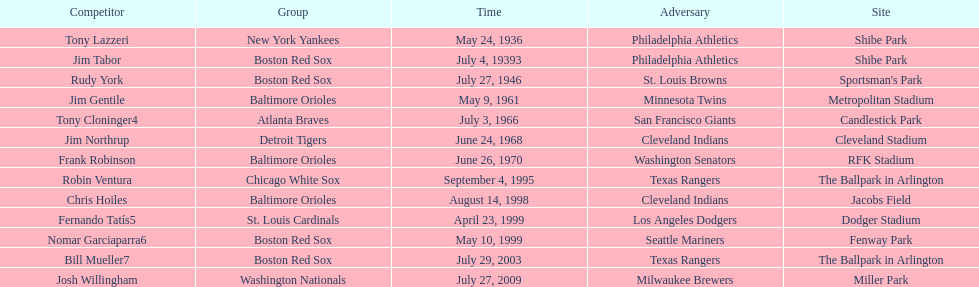Could you parse the entire table? {'header': ['Competitor', 'Group', 'Time', 'Adversary', 'Site'], 'rows': [['Tony Lazzeri', 'New York Yankees', 'May 24, 1936', 'Philadelphia Athletics', 'Shibe Park'], ['Jim Tabor', 'Boston Red Sox', 'July 4, 19393', 'Philadelphia Athletics', 'Shibe Park'], ['Rudy York', 'Boston Red Sox', 'July 27, 1946', 'St. Louis Browns', "Sportsman's Park"], ['Jim Gentile', 'Baltimore Orioles', 'May 9, 1961', 'Minnesota Twins', 'Metropolitan Stadium'], ['Tony Cloninger4', 'Atlanta Braves', 'July 3, 1966', 'San Francisco Giants', 'Candlestick Park'], ['Jim Northrup', 'Detroit Tigers', 'June 24, 1968', 'Cleveland Indians', 'Cleveland Stadium'], ['Frank Robinson', 'Baltimore Orioles', 'June 26, 1970', 'Washington Senators', 'RFK Stadium'], ['Robin Ventura', 'Chicago White Sox', 'September 4, 1995', 'Texas Rangers', 'The Ballpark in Arlington'], ['Chris Hoiles', 'Baltimore Orioles', 'August 14, 1998', 'Cleveland Indians', 'Jacobs Field'], ['Fernando Tatís5', 'St. Louis Cardinals', 'April 23, 1999', 'Los Angeles Dodgers', 'Dodger Stadium'], ['Nomar Garciaparra6', 'Boston Red Sox', 'May 10, 1999', 'Seattle Mariners', 'Fenway Park'], ['Bill Mueller7', 'Boston Red Sox', 'July 29, 2003', 'Texas Rangers', 'The Ballpark in Arlington'], ['Josh Willingham', 'Washington Nationals', 'July 27, 2009', 'Milwaukee Brewers', 'Miller Park']]} What was the name of the player who accomplished this in 1999 but played for the boston red sox? Nomar Garciaparra. 